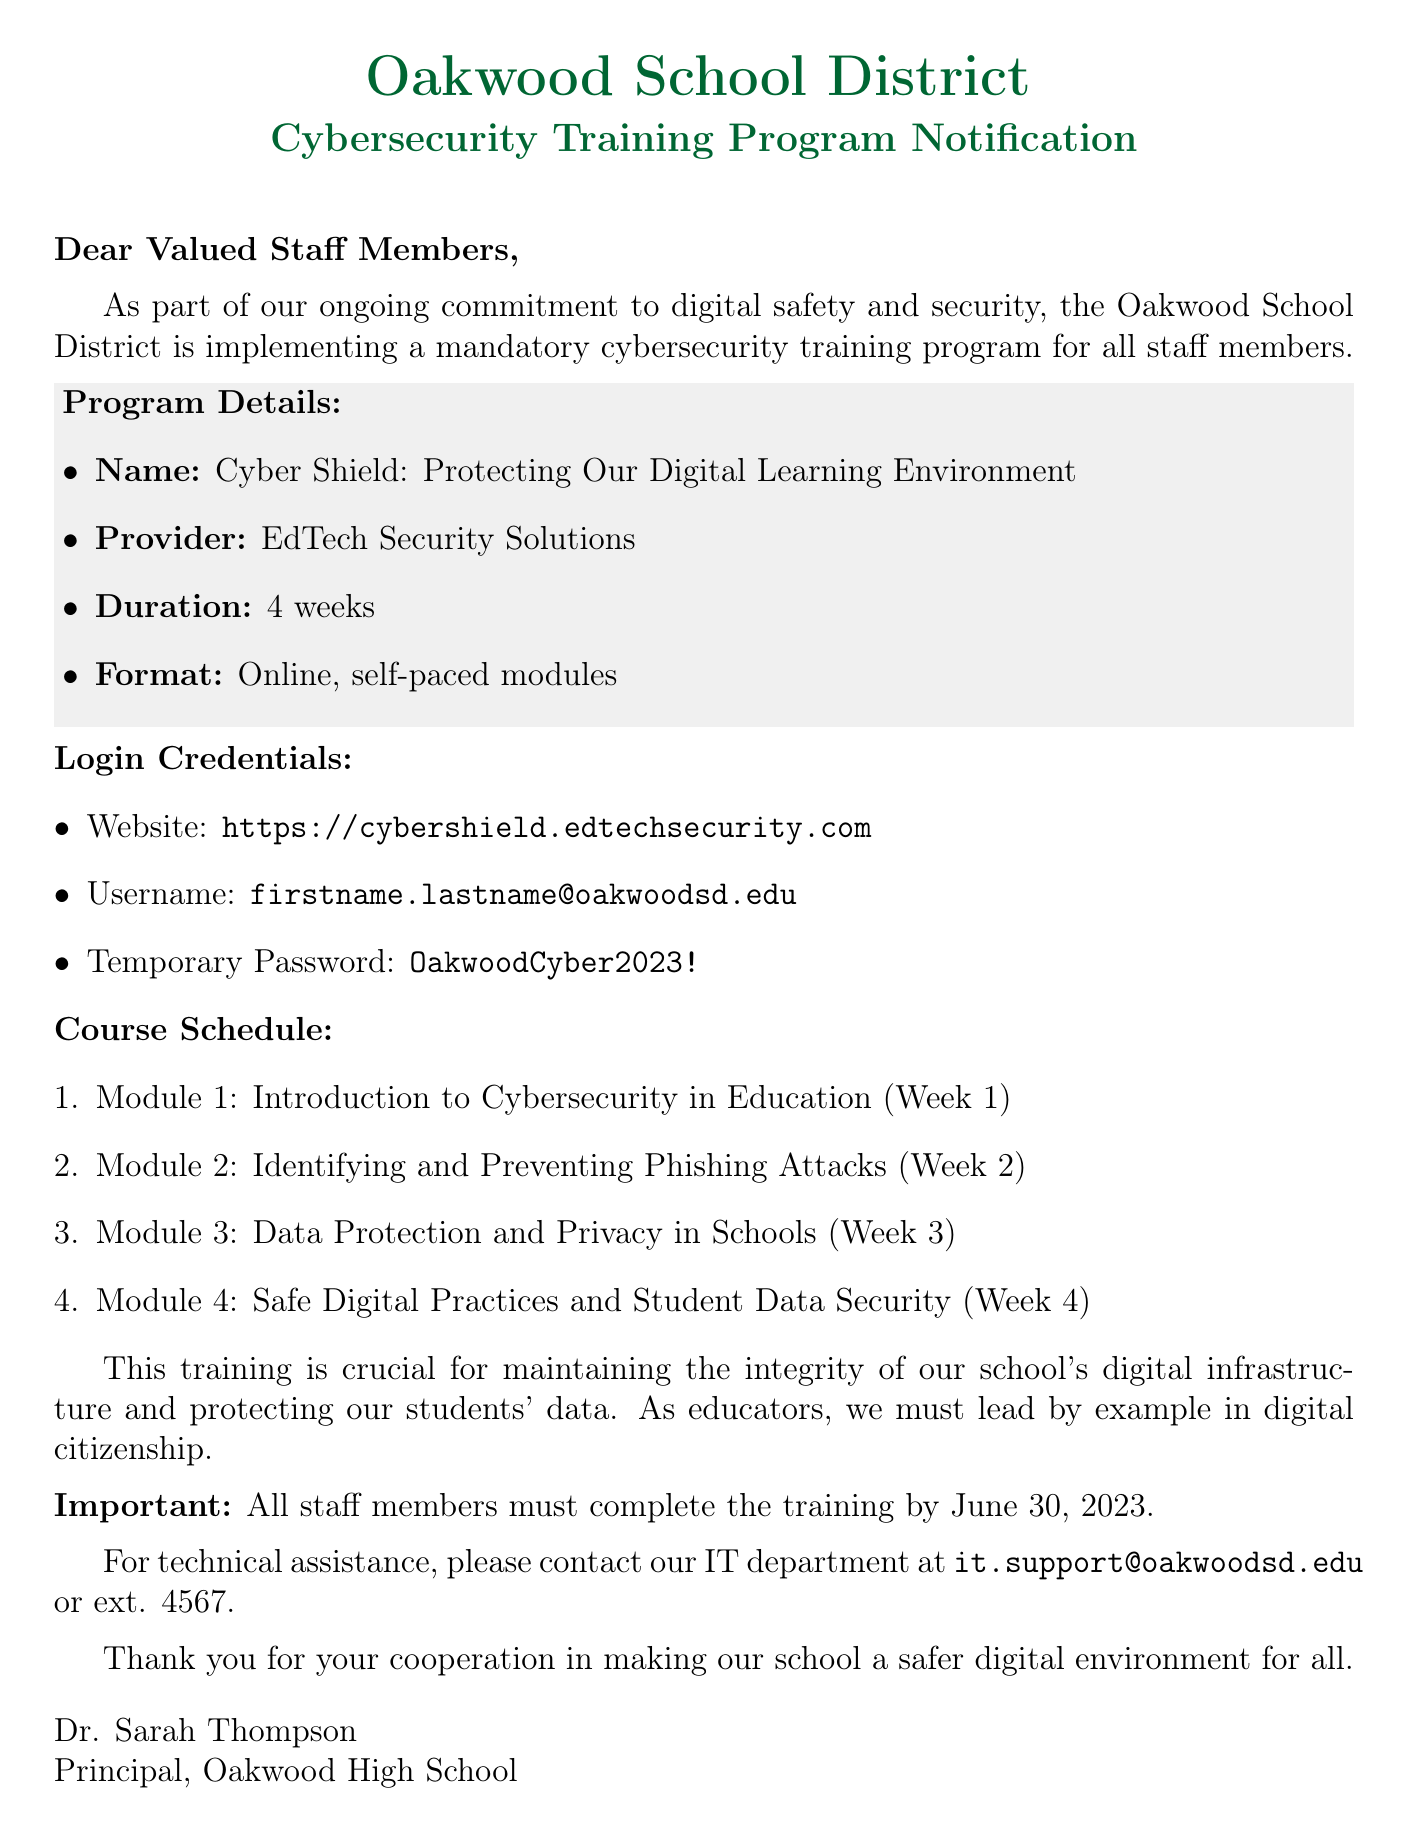What is the name of the program? The name of the program is mentioned in the program details section as "Cyber Shield: Protecting Our Digital Learning Environment."
Answer: Cyber Shield: Protecting Our Digital Learning Environment Who is the provider of the training program? The provider of the training program is specified in the program details section as "EdTech Security Solutions."
Answer: EdTech Security Solutions How long is the duration of the training program? The duration of the training program is listed in the program details section as "4 weeks."
Answer: 4 weeks What is the deadline for training completion? The deadline is provided in the important section of the document as "June 30, 2023."
Answer: June 30, 2023 What is the temporary password for the training? The temporary password is given in the login credentials section as "OakwoodCyber2023!"
Answer: OakwoodCyber2023! How many modules are there in the course schedule? The course schedule lists four modules, which can be counted as mentioned in the document.
Answer: 4 Which module focuses on phishing attacks? The specific module that focuses on phishing attacks is indicated as "Module 2: Identifying and Preventing Phishing Attacks."
Answer: Module 2: Identifying and Preventing Phishing Attacks What should staff do if they need technical assistance? Staff members should contact the IT department for technical assistance, as mentioned in the support section.
Answer: Contact IT department What is the format of the training program? The format of the training program is described in the program details section as "Online, self-paced modules."
Answer: Online, self-paced modules 